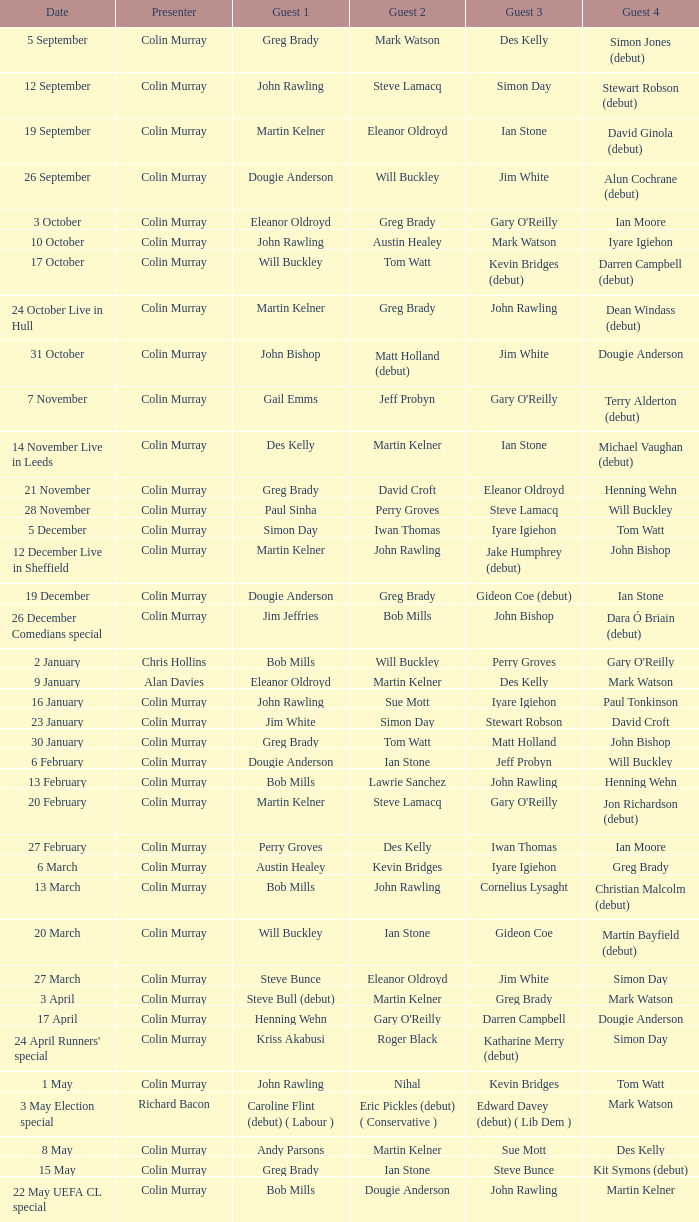Could you help me parse every detail presented in this table? {'header': ['Date', 'Presenter', 'Guest 1', 'Guest 2', 'Guest 3', 'Guest 4'], 'rows': [['5 September', 'Colin Murray', 'Greg Brady', 'Mark Watson', 'Des Kelly', 'Simon Jones (debut)'], ['12 September', 'Colin Murray', 'John Rawling', 'Steve Lamacq', 'Simon Day', 'Stewart Robson (debut)'], ['19 September', 'Colin Murray', 'Martin Kelner', 'Eleanor Oldroyd', 'Ian Stone', 'David Ginola (debut)'], ['26 September', 'Colin Murray', 'Dougie Anderson', 'Will Buckley', 'Jim White', 'Alun Cochrane (debut)'], ['3 October', 'Colin Murray', 'Eleanor Oldroyd', 'Greg Brady', "Gary O'Reilly", 'Ian Moore'], ['10 October', 'Colin Murray', 'John Rawling', 'Austin Healey', 'Mark Watson', 'Iyare Igiehon'], ['17 October', 'Colin Murray', 'Will Buckley', 'Tom Watt', 'Kevin Bridges (debut)', 'Darren Campbell (debut)'], ['24 October Live in Hull', 'Colin Murray', 'Martin Kelner', 'Greg Brady', 'John Rawling', 'Dean Windass (debut)'], ['31 October', 'Colin Murray', 'John Bishop', 'Matt Holland (debut)', 'Jim White', 'Dougie Anderson'], ['7 November', 'Colin Murray', 'Gail Emms', 'Jeff Probyn', "Gary O'Reilly", 'Terry Alderton (debut)'], ['14 November Live in Leeds', 'Colin Murray', 'Des Kelly', 'Martin Kelner', 'Ian Stone', 'Michael Vaughan (debut)'], ['21 November', 'Colin Murray', 'Greg Brady', 'David Croft', 'Eleanor Oldroyd', 'Henning Wehn'], ['28 November', 'Colin Murray', 'Paul Sinha', 'Perry Groves', 'Steve Lamacq', 'Will Buckley'], ['5 December', 'Colin Murray', 'Simon Day', 'Iwan Thomas', 'Iyare Igiehon', 'Tom Watt'], ['12 December Live in Sheffield', 'Colin Murray', 'Martin Kelner', 'John Rawling', 'Jake Humphrey (debut)', 'John Bishop'], ['19 December', 'Colin Murray', 'Dougie Anderson', 'Greg Brady', 'Gideon Coe (debut)', 'Ian Stone'], ['26 December Comedians special', 'Colin Murray', 'Jim Jeffries', 'Bob Mills', 'John Bishop', 'Dara Ó Briain (debut)'], ['2 January', 'Chris Hollins', 'Bob Mills', 'Will Buckley', 'Perry Groves', "Gary O'Reilly"], ['9 January', 'Alan Davies', 'Eleanor Oldroyd', 'Martin Kelner', 'Des Kelly', 'Mark Watson'], ['16 January', 'Colin Murray', 'John Rawling', 'Sue Mott', 'Iyare Igiehon', 'Paul Tonkinson'], ['23 January', 'Colin Murray', 'Jim White', 'Simon Day', 'Stewart Robson', 'David Croft'], ['30 January', 'Colin Murray', 'Greg Brady', 'Tom Watt', 'Matt Holland', 'John Bishop'], ['6 February', 'Colin Murray', 'Dougie Anderson', 'Ian Stone', 'Jeff Probyn', 'Will Buckley'], ['13 February', 'Colin Murray', 'Bob Mills', 'Lawrie Sanchez', 'John Rawling', 'Henning Wehn'], ['20 February', 'Colin Murray', 'Martin Kelner', 'Steve Lamacq', "Gary O'Reilly", 'Jon Richardson (debut)'], ['27 February', 'Colin Murray', 'Perry Groves', 'Des Kelly', 'Iwan Thomas', 'Ian Moore'], ['6 March', 'Colin Murray', 'Austin Healey', 'Kevin Bridges', 'Iyare Igiehon', 'Greg Brady'], ['13 March', 'Colin Murray', 'Bob Mills', 'John Rawling', 'Cornelius Lysaght', 'Christian Malcolm (debut)'], ['20 March', 'Colin Murray', 'Will Buckley', 'Ian Stone', 'Gideon Coe', 'Martin Bayfield (debut)'], ['27 March', 'Colin Murray', 'Steve Bunce', 'Eleanor Oldroyd', 'Jim White', 'Simon Day'], ['3 April', 'Colin Murray', 'Steve Bull (debut)', 'Martin Kelner', 'Greg Brady', 'Mark Watson'], ['17 April', 'Colin Murray', 'Henning Wehn', "Gary O'Reilly", 'Darren Campbell', 'Dougie Anderson'], ["24 April Runners' special", 'Colin Murray', 'Kriss Akabusi', 'Roger Black', 'Katharine Merry (debut)', 'Simon Day'], ['1 May', 'Colin Murray', 'John Rawling', 'Nihal', 'Kevin Bridges', 'Tom Watt'], ['3 May Election special', 'Richard Bacon', 'Caroline Flint (debut) ( Labour )', 'Eric Pickles (debut) ( Conservative )', 'Edward Davey (debut) ( Lib Dem )', 'Mark Watson'], ['8 May', 'Colin Murray', 'Andy Parsons', 'Martin Kelner', 'Sue Mott', 'Des Kelly'], ['15 May', 'Colin Murray', 'Greg Brady', 'Ian Stone', 'Steve Bunce', 'Kit Symons (debut)'], ['22 May UEFA CL special', 'Colin Murray', 'Bob Mills', 'Dougie Anderson', 'John Rawling', 'Martin Kelner']]} How many unique individuals have been guest 1 on episodes that have des kelly as guest 4? 1.0. 